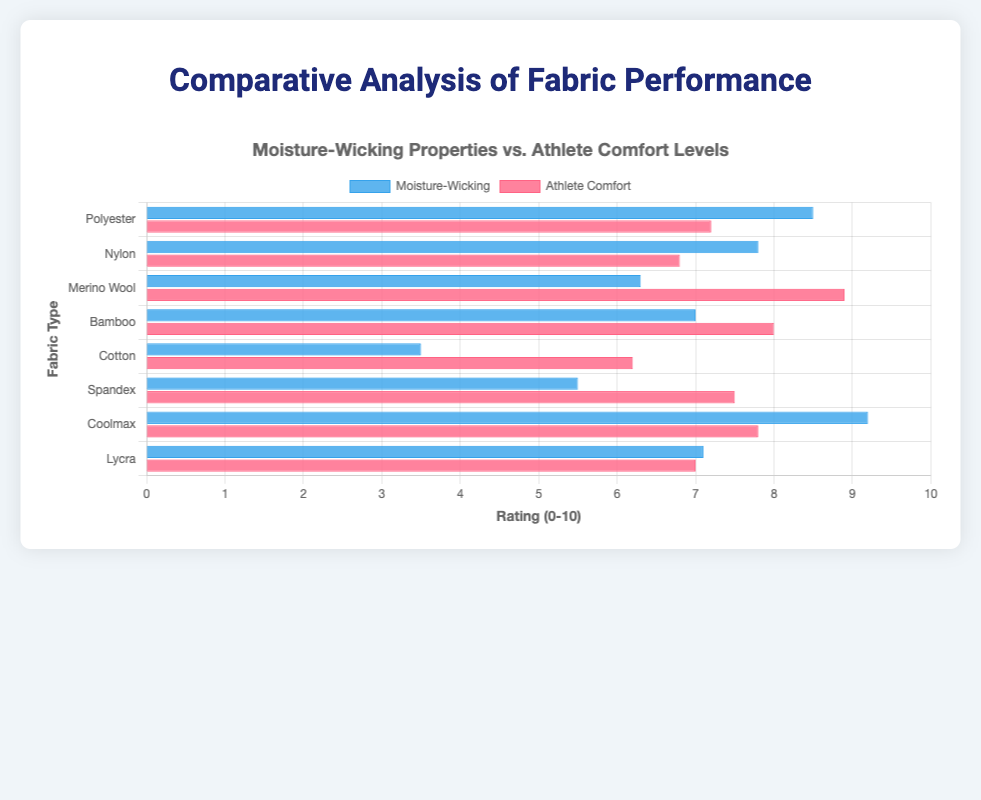Which fabric has the highest moisture-wicking property? By looking at the horizontal bars corresponding to moisture-wicking, identify the one that extends the farthest to the right. Coolmax has the highest moisture-wicking property with a rating of 9.2
Answer: Coolmax Which fabric has the lowest athlete comfort level? By looking at the red bars corresponding to athlete comfort, identify the shortest one. Cotton has the lowest athlete comfort level with a rating of 6.2
Answer: Cotton What is the difference in moisture-wicking properties between Polyester and Cotton? Find the length of the blue bars corresponding to Polyester and Cotton, and subtract the value of Cotton from Polyester. Polyester has a moisture-wicking rating of 8.5, while Cotton has a rating of 3.5, so the difference is 8.5 - 3.5 = 5.0
Answer: 5.0 How does Bamboo's athlete comfort level compare to Nylon's? Look at the red bars for Bamboo and Nylon and compare their lengths. Bamboo has an athlete comfort rating of 8.0, while Nylon has a rating of 6.8, so Bamboo's athlete comfort level is higher by 8.0 - 6.8 = 1.2
Answer: Bamboo is higher by 1.2 Which fabric shows a better balance between moisture-wicking and athlete comfort? Look for fabric where both blue and red bars are relatively long and close to each other. Coolmax has a moisture-wicking of 9.2 and athlete comfort of 7.8, indicating a strong balance
Answer: Coolmax What is the average moisture-wicking rating across all fabrics? Add all moisture-wicking ratings and divide by the number of fabrics. Sum: 8.5 + 7.8 + 6.3 + 7.0 + 3.5 + 5.5 + 9.2 + 7.1 = 54.9; Number of fabrics: 8; Average = 54.9 / 8 = 6.86
Answer: 6.86 What is the median athlete comfort level among the fabrics? Arrange the athlete comfort levels in ascending order and find the median. Ordered: 6.2, 6.8, 7.0, 7.2, 7.5, 7.8, 8.0, 8.9; With 8 data points: Median = (7.2 + 7.5) / 2 = 7.35
Answer: 7.35 